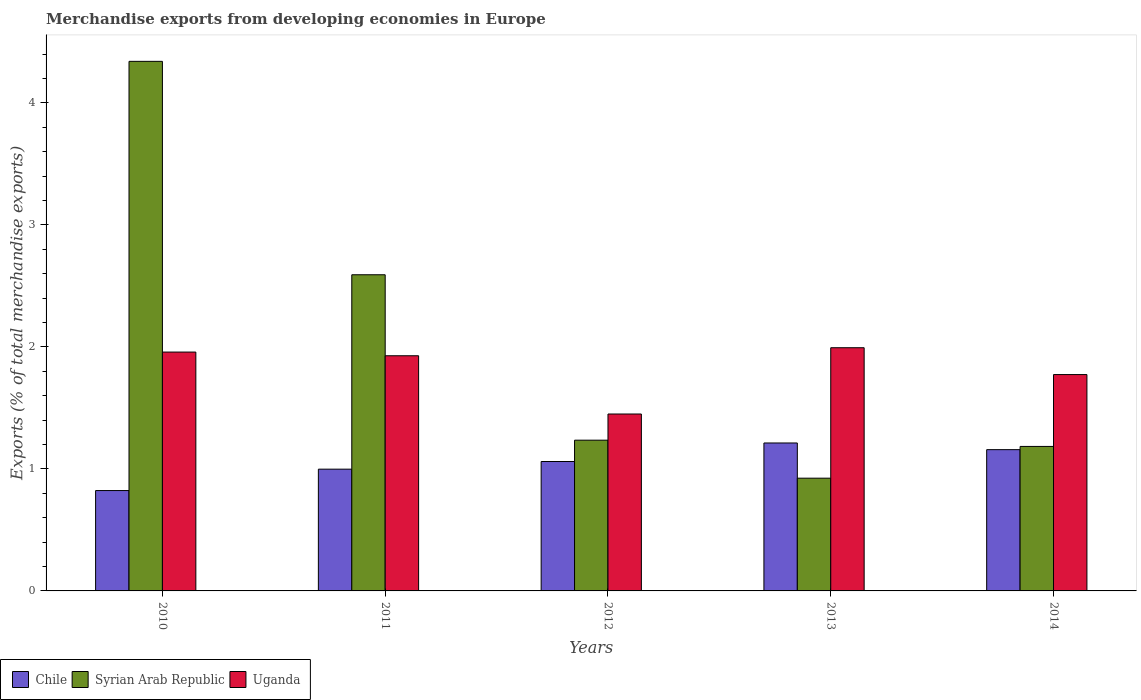How many different coloured bars are there?
Provide a succinct answer. 3. Are the number of bars per tick equal to the number of legend labels?
Make the answer very short. Yes. How many bars are there on the 2nd tick from the left?
Provide a succinct answer. 3. How many bars are there on the 1st tick from the right?
Make the answer very short. 3. What is the percentage of total merchandise exports in Syrian Arab Republic in 2011?
Provide a succinct answer. 2.59. Across all years, what is the maximum percentage of total merchandise exports in Syrian Arab Republic?
Your answer should be compact. 4.34. Across all years, what is the minimum percentage of total merchandise exports in Chile?
Provide a succinct answer. 0.82. In which year was the percentage of total merchandise exports in Chile minimum?
Keep it short and to the point. 2010. What is the total percentage of total merchandise exports in Uganda in the graph?
Make the answer very short. 9.1. What is the difference between the percentage of total merchandise exports in Syrian Arab Republic in 2012 and that in 2013?
Offer a terse response. 0.31. What is the difference between the percentage of total merchandise exports in Uganda in 2012 and the percentage of total merchandise exports in Chile in 2013?
Ensure brevity in your answer.  0.24. What is the average percentage of total merchandise exports in Chile per year?
Offer a terse response. 1.05. In the year 2013, what is the difference between the percentage of total merchandise exports in Uganda and percentage of total merchandise exports in Syrian Arab Republic?
Ensure brevity in your answer.  1.07. In how many years, is the percentage of total merchandise exports in Uganda greater than 0.8 %?
Offer a terse response. 5. What is the ratio of the percentage of total merchandise exports in Chile in 2010 to that in 2011?
Your answer should be very brief. 0.82. Is the percentage of total merchandise exports in Chile in 2010 less than that in 2011?
Keep it short and to the point. Yes. Is the difference between the percentage of total merchandise exports in Uganda in 2010 and 2013 greater than the difference between the percentage of total merchandise exports in Syrian Arab Republic in 2010 and 2013?
Ensure brevity in your answer.  No. What is the difference between the highest and the second highest percentage of total merchandise exports in Uganda?
Give a very brief answer. 0.04. What is the difference between the highest and the lowest percentage of total merchandise exports in Syrian Arab Republic?
Offer a very short reply. 3.42. In how many years, is the percentage of total merchandise exports in Chile greater than the average percentage of total merchandise exports in Chile taken over all years?
Give a very brief answer. 3. Is the sum of the percentage of total merchandise exports in Syrian Arab Republic in 2011 and 2013 greater than the maximum percentage of total merchandise exports in Uganda across all years?
Your response must be concise. Yes. What does the 3rd bar from the left in 2010 represents?
Your answer should be compact. Uganda. What does the 3rd bar from the right in 2010 represents?
Offer a very short reply. Chile. How many bars are there?
Provide a short and direct response. 15. How many years are there in the graph?
Offer a very short reply. 5. What is the difference between two consecutive major ticks on the Y-axis?
Offer a terse response. 1. Are the values on the major ticks of Y-axis written in scientific E-notation?
Offer a terse response. No. Does the graph contain any zero values?
Make the answer very short. No. Where does the legend appear in the graph?
Your answer should be compact. Bottom left. How many legend labels are there?
Your answer should be compact. 3. How are the legend labels stacked?
Your response must be concise. Horizontal. What is the title of the graph?
Give a very brief answer. Merchandise exports from developing economies in Europe. Does "Poland" appear as one of the legend labels in the graph?
Your answer should be compact. No. What is the label or title of the X-axis?
Give a very brief answer. Years. What is the label or title of the Y-axis?
Provide a succinct answer. Exports (% of total merchandise exports). What is the Exports (% of total merchandise exports) of Chile in 2010?
Offer a terse response. 0.82. What is the Exports (% of total merchandise exports) of Syrian Arab Republic in 2010?
Keep it short and to the point. 4.34. What is the Exports (% of total merchandise exports) of Uganda in 2010?
Make the answer very short. 1.96. What is the Exports (% of total merchandise exports) of Chile in 2011?
Provide a succinct answer. 1. What is the Exports (% of total merchandise exports) in Syrian Arab Republic in 2011?
Your answer should be compact. 2.59. What is the Exports (% of total merchandise exports) of Uganda in 2011?
Keep it short and to the point. 1.93. What is the Exports (% of total merchandise exports) of Chile in 2012?
Give a very brief answer. 1.06. What is the Exports (% of total merchandise exports) in Syrian Arab Republic in 2012?
Offer a very short reply. 1.24. What is the Exports (% of total merchandise exports) in Uganda in 2012?
Provide a short and direct response. 1.45. What is the Exports (% of total merchandise exports) of Chile in 2013?
Ensure brevity in your answer.  1.21. What is the Exports (% of total merchandise exports) in Syrian Arab Republic in 2013?
Provide a short and direct response. 0.92. What is the Exports (% of total merchandise exports) in Uganda in 2013?
Offer a very short reply. 1.99. What is the Exports (% of total merchandise exports) in Chile in 2014?
Make the answer very short. 1.16. What is the Exports (% of total merchandise exports) of Syrian Arab Republic in 2014?
Your answer should be very brief. 1.18. What is the Exports (% of total merchandise exports) in Uganda in 2014?
Offer a very short reply. 1.77. Across all years, what is the maximum Exports (% of total merchandise exports) in Chile?
Provide a short and direct response. 1.21. Across all years, what is the maximum Exports (% of total merchandise exports) of Syrian Arab Republic?
Make the answer very short. 4.34. Across all years, what is the maximum Exports (% of total merchandise exports) of Uganda?
Your answer should be very brief. 1.99. Across all years, what is the minimum Exports (% of total merchandise exports) in Chile?
Your answer should be very brief. 0.82. Across all years, what is the minimum Exports (% of total merchandise exports) of Syrian Arab Republic?
Make the answer very short. 0.92. Across all years, what is the minimum Exports (% of total merchandise exports) in Uganda?
Your response must be concise. 1.45. What is the total Exports (% of total merchandise exports) in Chile in the graph?
Make the answer very short. 5.25. What is the total Exports (% of total merchandise exports) of Syrian Arab Republic in the graph?
Make the answer very short. 10.28. What is the total Exports (% of total merchandise exports) of Uganda in the graph?
Your answer should be compact. 9.1. What is the difference between the Exports (% of total merchandise exports) in Chile in 2010 and that in 2011?
Your answer should be very brief. -0.18. What is the difference between the Exports (% of total merchandise exports) in Syrian Arab Republic in 2010 and that in 2011?
Your response must be concise. 1.75. What is the difference between the Exports (% of total merchandise exports) in Uganda in 2010 and that in 2011?
Provide a succinct answer. 0.03. What is the difference between the Exports (% of total merchandise exports) in Chile in 2010 and that in 2012?
Offer a terse response. -0.24. What is the difference between the Exports (% of total merchandise exports) in Syrian Arab Republic in 2010 and that in 2012?
Your answer should be compact. 3.1. What is the difference between the Exports (% of total merchandise exports) of Uganda in 2010 and that in 2012?
Your response must be concise. 0.51. What is the difference between the Exports (% of total merchandise exports) in Chile in 2010 and that in 2013?
Your response must be concise. -0.39. What is the difference between the Exports (% of total merchandise exports) of Syrian Arab Republic in 2010 and that in 2013?
Ensure brevity in your answer.  3.42. What is the difference between the Exports (% of total merchandise exports) of Uganda in 2010 and that in 2013?
Your answer should be compact. -0.04. What is the difference between the Exports (% of total merchandise exports) of Chile in 2010 and that in 2014?
Provide a succinct answer. -0.34. What is the difference between the Exports (% of total merchandise exports) in Syrian Arab Republic in 2010 and that in 2014?
Offer a terse response. 3.16. What is the difference between the Exports (% of total merchandise exports) in Uganda in 2010 and that in 2014?
Your answer should be compact. 0.18. What is the difference between the Exports (% of total merchandise exports) of Chile in 2011 and that in 2012?
Give a very brief answer. -0.06. What is the difference between the Exports (% of total merchandise exports) of Syrian Arab Republic in 2011 and that in 2012?
Provide a succinct answer. 1.36. What is the difference between the Exports (% of total merchandise exports) in Uganda in 2011 and that in 2012?
Provide a short and direct response. 0.48. What is the difference between the Exports (% of total merchandise exports) of Chile in 2011 and that in 2013?
Provide a succinct answer. -0.21. What is the difference between the Exports (% of total merchandise exports) in Syrian Arab Republic in 2011 and that in 2013?
Your answer should be very brief. 1.67. What is the difference between the Exports (% of total merchandise exports) of Uganda in 2011 and that in 2013?
Provide a short and direct response. -0.07. What is the difference between the Exports (% of total merchandise exports) of Chile in 2011 and that in 2014?
Make the answer very short. -0.16. What is the difference between the Exports (% of total merchandise exports) in Syrian Arab Republic in 2011 and that in 2014?
Make the answer very short. 1.41. What is the difference between the Exports (% of total merchandise exports) of Uganda in 2011 and that in 2014?
Make the answer very short. 0.15. What is the difference between the Exports (% of total merchandise exports) of Chile in 2012 and that in 2013?
Offer a terse response. -0.15. What is the difference between the Exports (% of total merchandise exports) in Syrian Arab Republic in 2012 and that in 2013?
Give a very brief answer. 0.31. What is the difference between the Exports (% of total merchandise exports) of Uganda in 2012 and that in 2013?
Your answer should be compact. -0.54. What is the difference between the Exports (% of total merchandise exports) in Chile in 2012 and that in 2014?
Keep it short and to the point. -0.1. What is the difference between the Exports (% of total merchandise exports) in Syrian Arab Republic in 2012 and that in 2014?
Your answer should be compact. 0.05. What is the difference between the Exports (% of total merchandise exports) of Uganda in 2012 and that in 2014?
Ensure brevity in your answer.  -0.32. What is the difference between the Exports (% of total merchandise exports) in Chile in 2013 and that in 2014?
Make the answer very short. 0.05. What is the difference between the Exports (% of total merchandise exports) in Syrian Arab Republic in 2013 and that in 2014?
Your answer should be very brief. -0.26. What is the difference between the Exports (% of total merchandise exports) in Uganda in 2013 and that in 2014?
Keep it short and to the point. 0.22. What is the difference between the Exports (% of total merchandise exports) of Chile in 2010 and the Exports (% of total merchandise exports) of Syrian Arab Republic in 2011?
Provide a short and direct response. -1.77. What is the difference between the Exports (% of total merchandise exports) of Chile in 2010 and the Exports (% of total merchandise exports) of Uganda in 2011?
Provide a short and direct response. -1.1. What is the difference between the Exports (% of total merchandise exports) of Syrian Arab Republic in 2010 and the Exports (% of total merchandise exports) of Uganda in 2011?
Give a very brief answer. 2.41. What is the difference between the Exports (% of total merchandise exports) in Chile in 2010 and the Exports (% of total merchandise exports) in Syrian Arab Republic in 2012?
Your response must be concise. -0.41. What is the difference between the Exports (% of total merchandise exports) of Chile in 2010 and the Exports (% of total merchandise exports) of Uganda in 2012?
Your answer should be compact. -0.63. What is the difference between the Exports (% of total merchandise exports) of Syrian Arab Republic in 2010 and the Exports (% of total merchandise exports) of Uganda in 2012?
Your response must be concise. 2.89. What is the difference between the Exports (% of total merchandise exports) of Chile in 2010 and the Exports (% of total merchandise exports) of Syrian Arab Republic in 2013?
Offer a terse response. -0.1. What is the difference between the Exports (% of total merchandise exports) of Chile in 2010 and the Exports (% of total merchandise exports) of Uganda in 2013?
Your answer should be very brief. -1.17. What is the difference between the Exports (% of total merchandise exports) in Syrian Arab Republic in 2010 and the Exports (% of total merchandise exports) in Uganda in 2013?
Ensure brevity in your answer.  2.35. What is the difference between the Exports (% of total merchandise exports) in Chile in 2010 and the Exports (% of total merchandise exports) in Syrian Arab Republic in 2014?
Your answer should be compact. -0.36. What is the difference between the Exports (% of total merchandise exports) of Chile in 2010 and the Exports (% of total merchandise exports) of Uganda in 2014?
Ensure brevity in your answer.  -0.95. What is the difference between the Exports (% of total merchandise exports) in Syrian Arab Republic in 2010 and the Exports (% of total merchandise exports) in Uganda in 2014?
Make the answer very short. 2.57. What is the difference between the Exports (% of total merchandise exports) of Chile in 2011 and the Exports (% of total merchandise exports) of Syrian Arab Republic in 2012?
Provide a short and direct response. -0.24. What is the difference between the Exports (% of total merchandise exports) in Chile in 2011 and the Exports (% of total merchandise exports) in Uganda in 2012?
Give a very brief answer. -0.45. What is the difference between the Exports (% of total merchandise exports) in Syrian Arab Republic in 2011 and the Exports (% of total merchandise exports) in Uganda in 2012?
Give a very brief answer. 1.14. What is the difference between the Exports (% of total merchandise exports) of Chile in 2011 and the Exports (% of total merchandise exports) of Syrian Arab Republic in 2013?
Provide a short and direct response. 0.07. What is the difference between the Exports (% of total merchandise exports) of Chile in 2011 and the Exports (% of total merchandise exports) of Uganda in 2013?
Give a very brief answer. -1. What is the difference between the Exports (% of total merchandise exports) in Syrian Arab Republic in 2011 and the Exports (% of total merchandise exports) in Uganda in 2013?
Provide a short and direct response. 0.6. What is the difference between the Exports (% of total merchandise exports) in Chile in 2011 and the Exports (% of total merchandise exports) in Syrian Arab Republic in 2014?
Ensure brevity in your answer.  -0.19. What is the difference between the Exports (% of total merchandise exports) of Chile in 2011 and the Exports (% of total merchandise exports) of Uganda in 2014?
Provide a succinct answer. -0.78. What is the difference between the Exports (% of total merchandise exports) of Syrian Arab Republic in 2011 and the Exports (% of total merchandise exports) of Uganda in 2014?
Your response must be concise. 0.82. What is the difference between the Exports (% of total merchandise exports) of Chile in 2012 and the Exports (% of total merchandise exports) of Syrian Arab Republic in 2013?
Provide a short and direct response. 0.14. What is the difference between the Exports (% of total merchandise exports) in Chile in 2012 and the Exports (% of total merchandise exports) in Uganda in 2013?
Offer a terse response. -0.93. What is the difference between the Exports (% of total merchandise exports) in Syrian Arab Republic in 2012 and the Exports (% of total merchandise exports) in Uganda in 2013?
Offer a terse response. -0.76. What is the difference between the Exports (% of total merchandise exports) of Chile in 2012 and the Exports (% of total merchandise exports) of Syrian Arab Republic in 2014?
Keep it short and to the point. -0.12. What is the difference between the Exports (% of total merchandise exports) in Chile in 2012 and the Exports (% of total merchandise exports) in Uganda in 2014?
Your answer should be very brief. -0.71. What is the difference between the Exports (% of total merchandise exports) of Syrian Arab Republic in 2012 and the Exports (% of total merchandise exports) of Uganda in 2014?
Ensure brevity in your answer.  -0.54. What is the difference between the Exports (% of total merchandise exports) in Chile in 2013 and the Exports (% of total merchandise exports) in Syrian Arab Republic in 2014?
Offer a very short reply. 0.03. What is the difference between the Exports (% of total merchandise exports) of Chile in 2013 and the Exports (% of total merchandise exports) of Uganda in 2014?
Provide a succinct answer. -0.56. What is the difference between the Exports (% of total merchandise exports) of Syrian Arab Republic in 2013 and the Exports (% of total merchandise exports) of Uganda in 2014?
Provide a succinct answer. -0.85. What is the average Exports (% of total merchandise exports) of Chile per year?
Your answer should be compact. 1.05. What is the average Exports (% of total merchandise exports) in Syrian Arab Republic per year?
Your answer should be compact. 2.06. What is the average Exports (% of total merchandise exports) of Uganda per year?
Make the answer very short. 1.82. In the year 2010, what is the difference between the Exports (% of total merchandise exports) of Chile and Exports (% of total merchandise exports) of Syrian Arab Republic?
Offer a very short reply. -3.52. In the year 2010, what is the difference between the Exports (% of total merchandise exports) in Chile and Exports (% of total merchandise exports) in Uganda?
Give a very brief answer. -1.14. In the year 2010, what is the difference between the Exports (% of total merchandise exports) of Syrian Arab Republic and Exports (% of total merchandise exports) of Uganda?
Your answer should be very brief. 2.38. In the year 2011, what is the difference between the Exports (% of total merchandise exports) of Chile and Exports (% of total merchandise exports) of Syrian Arab Republic?
Give a very brief answer. -1.59. In the year 2011, what is the difference between the Exports (% of total merchandise exports) in Chile and Exports (% of total merchandise exports) in Uganda?
Offer a very short reply. -0.93. In the year 2011, what is the difference between the Exports (% of total merchandise exports) of Syrian Arab Republic and Exports (% of total merchandise exports) of Uganda?
Keep it short and to the point. 0.66. In the year 2012, what is the difference between the Exports (% of total merchandise exports) in Chile and Exports (% of total merchandise exports) in Syrian Arab Republic?
Make the answer very short. -0.17. In the year 2012, what is the difference between the Exports (% of total merchandise exports) in Chile and Exports (% of total merchandise exports) in Uganda?
Your response must be concise. -0.39. In the year 2012, what is the difference between the Exports (% of total merchandise exports) in Syrian Arab Republic and Exports (% of total merchandise exports) in Uganda?
Provide a short and direct response. -0.21. In the year 2013, what is the difference between the Exports (% of total merchandise exports) of Chile and Exports (% of total merchandise exports) of Syrian Arab Republic?
Offer a very short reply. 0.29. In the year 2013, what is the difference between the Exports (% of total merchandise exports) in Chile and Exports (% of total merchandise exports) in Uganda?
Provide a succinct answer. -0.78. In the year 2013, what is the difference between the Exports (% of total merchandise exports) of Syrian Arab Republic and Exports (% of total merchandise exports) of Uganda?
Provide a short and direct response. -1.07. In the year 2014, what is the difference between the Exports (% of total merchandise exports) in Chile and Exports (% of total merchandise exports) in Syrian Arab Republic?
Offer a terse response. -0.03. In the year 2014, what is the difference between the Exports (% of total merchandise exports) in Chile and Exports (% of total merchandise exports) in Uganda?
Offer a terse response. -0.62. In the year 2014, what is the difference between the Exports (% of total merchandise exports) in Syrian Arab Republic and Exports (% of total merchandise exports) in Uganda?
Ensure brevity in your answer.  -0.59. What is the ratio of the Exports (% of total merchandise exports) in Chile in 2010 to that in 2011?
Your answer should be compact. 0.82. What is the ratio of the Exports (% of total merchandise exports) in Syrian Arab Republic in 2010 to that in 2011?
Provide a succinct answer. 1.68. What is the ratio of the Exports (% of total merchandise exports) of Uganda in 2010 to that in 2011?
Your answer should be compact. 1.02. What is the ratio of the Exports (% of total merchandise exports) in Chile in 2010 to that in 2012?
Provide a short and direct response. 0.78. What is the ratio of the Exports (% of total merchandise exports) of Syrian Arab Republic in 2010 to that in 2012?
Offer a terse response. 3.51. What is the ratio of the Exports (% of total merchandise exports) in Uganda in 2010 to that in 2012?
Offer a very short reply. 1.35. What is the ratio of the Exports (% of total merchandise exports) of Chile in 2010 to that in 2013?
Provide a succinct answer. 0.68. What is the ratio of the Exports (% of total merchandise exports) of Syrian Arab Republic in 2010 to that in 2013?
Your answer should be compact. 4.7. What is the ratio of the Exports (% of total merchandise exports) of Uganda in 2010 to that in 2013?
Make the answer very short. 0.98. What is the ratio of the Exports (% of total merchandise exports) of Chile in 2010 to that in 2014?
Your answer should be compact. 0.71. What is the ratio of the Exports (% of total merchandise exports) in Syrian Arab Republic in 2010 to that in 2014?
Your response must be concise. 3.67. What is the ratio of the Exports (% of total merchandise exports) in Uganda in 2010 to that in 2014?
Ensure brevity in your answer.  1.1. What is the ratio of the Exports (% of total merchandise exports) of Chile in 2011 to that in 2012?
Your answer should be compact. 0.94. What is the ratio of the Exports (% of total merchandise exports) of Syrian Arab Republic in 2011 to that in 2012?
Offer a terse response. 2.1. What is the ratio of the Exports (% of total merchandise exports) of Uganda in 2011 to that in 2012?
Keep it short and to the point. 1.33. What is the ratio of the Exports (% of total merchandise exports) in Chile in 2011 to that in 2013?
Keep it short and to the point. 0.82. What is the ratio of the Exports (% of total merchandise exports) in Syrian Arab Republic in 2011 to that in 2013?
Provide a short and direct response. 2.8. What is the ratio of the Exports (% of total merchandise exports) in Chile in 2011 to that in 2014?
Keep it short and to the point. 0.86. What is the ratio of the Exports (% of total merchandise exports) of Syrian Arab Republic in 2011 to that in 2014?
Give a very brief answer. 2.19. What is the ratio of the Exports (% of total merchandise exports) in Uganda in 2011 to that in 2014?
Your response must be concise. 1.09. What is the ratio of the Exports (% of total merchandise exports) in Chile in 2012 to that in 2013?
Ensure brevity in your answer.  0.87. What is the ratio of the Exports (% of total merchandise exports) in Syrian Arab Republic in 2012 to that in 2013?
Keep it short and to the point. 1.34. What is the ratio of the Exports (% of total merchandise exports) in Uganda in 2012 to that in 2013?
Keep it short and to the point. 0.73. What is the ratio of the Exports (% of total merchandise exports) in Chile in 2012 to that in 2014?
Provide a short and direct response. 0.92. What is the ratio of the Exports (% of total merchandise exports) of Syrian Arab Republic in 2012 to that in 2014?
Your answer should be very brief. 1.04. What is the ratio of the Exports (% of total merchandise exports) of Uganda in 2012 to that in 2014?
Make the answer very short. 0.82. What is the ratio of the Exports (% of total merchandise exports) of Chile in 2013 to that in 2014?
Keep it short and to the point. 1.05. What is the ratio of the Exports (% of total merchandise exports) in Syrian Arab Republic in 2013 to that in 2014?
Your answer should be very brief. 0.78. What is the ratio of the Exports (% of total merchandise exports) of Uganda in 2013 to that in 2014?
Offer a very short reply. 1.12. What is the difference between the highest and the second highest Exports (% of total merchandise exports) in Chile?
Provide a short and direct response. 0.05. What is the difference between the highest and the second highest Exports (% of total merchandise exports) of Syrian Arab Republic?
Make the answer very short. 1.75. What is the difference between the highest and the second highest Exports (% of total merchandise exports) of Uganda?
Keep it short and to the point. 0.04. What is the difference between the highest and the lowest Exports (% of total merchandise exports) in Chile?
Ensure brevity in your answer.  0.39. What is the difference between the highest and the lowest Exports (% of total merchandise exports) in Syrian Arab Republic?
Provide a short and direct response. 3.42. What is the difference between the highest and the lowest Exports (% of total merchandise exports) in Uganda?
Offer a very short reply. 0.54. 